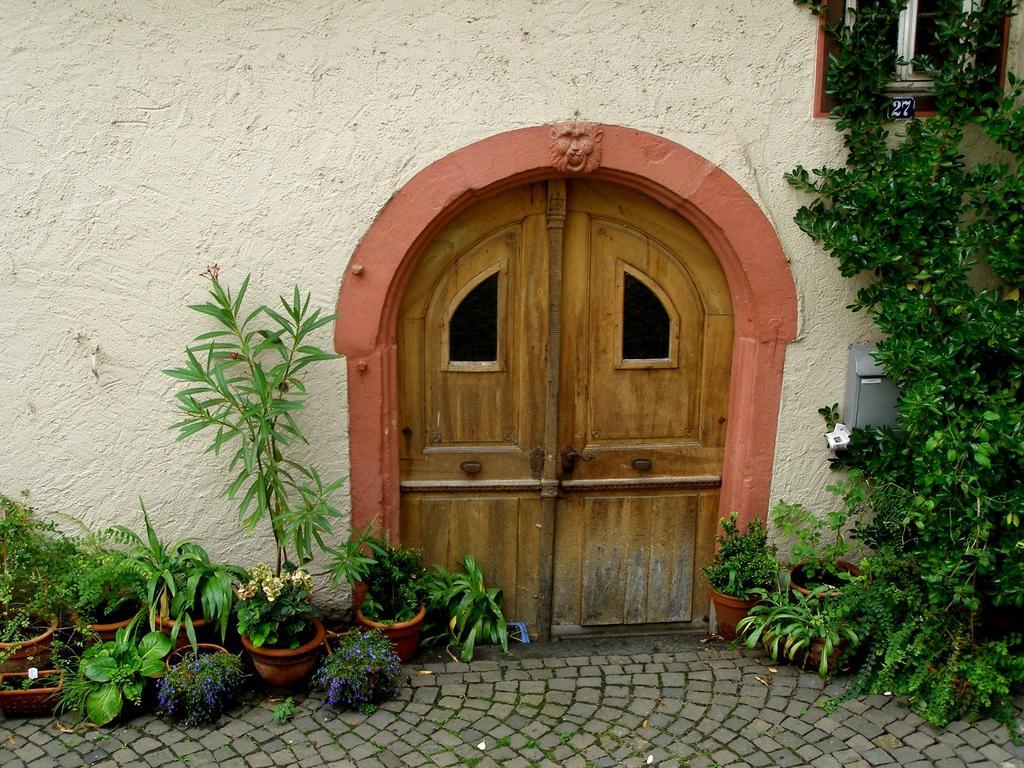Describe this image in one or two sentences. In this image I can see a small wooden door. To the side of the door there are many flower pots with purple and white color flowers. To the right I can see the plant. 